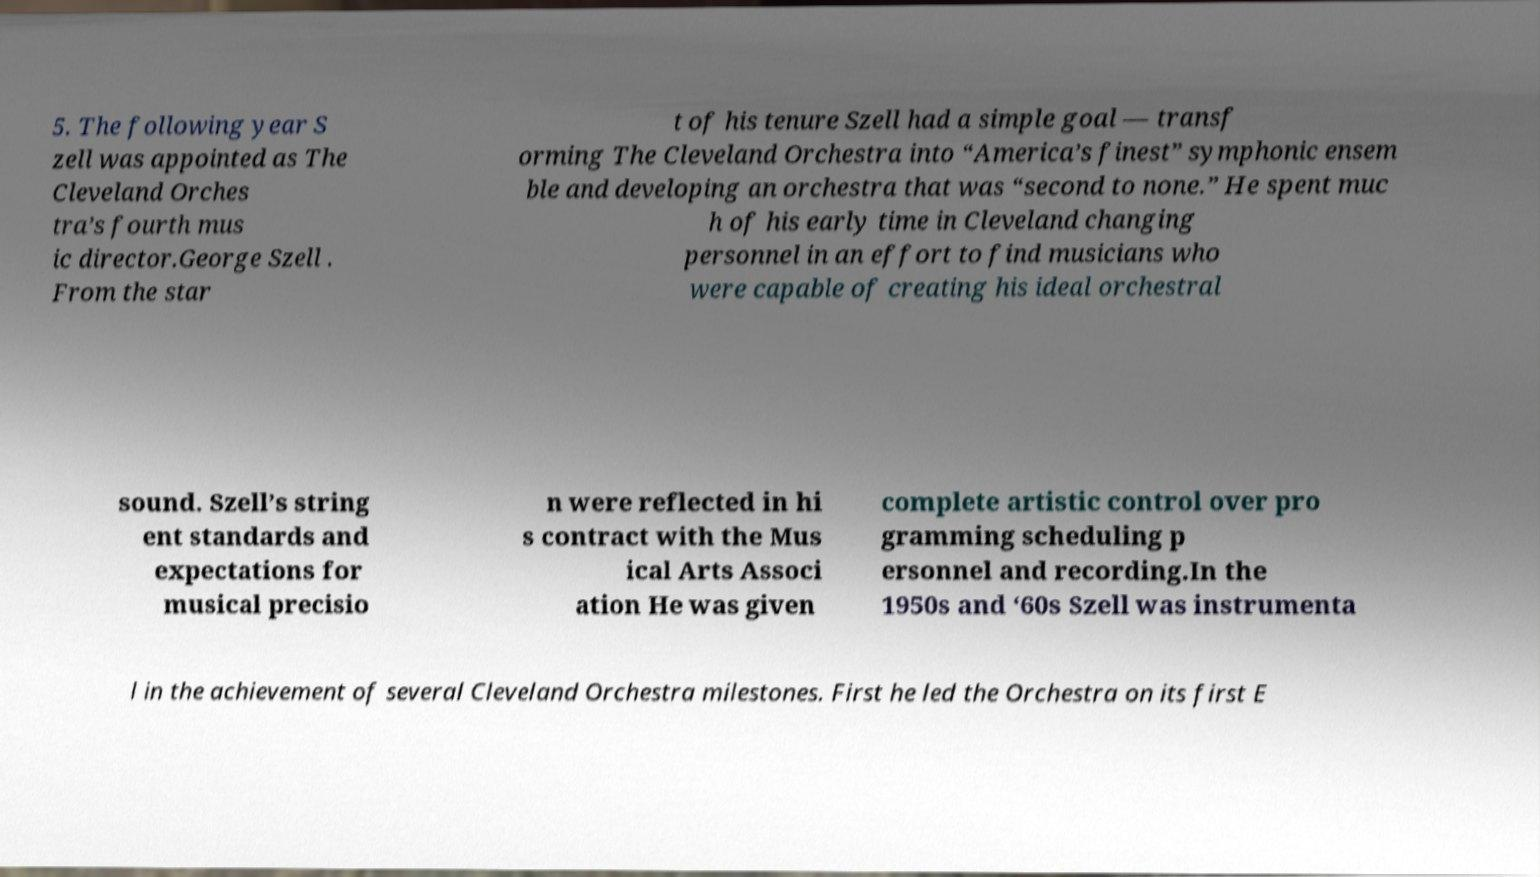Please identify and transcribe the text found in this image. 5. The following year S zell was appointed as The Cleveland Orches tra’s fourth mus ic director.George Szell . From the star t of his tenure Szell had a simple goal — transf orming The Cleveland Orchestra into “America’s finest” symphonic ensem ble and developing an orchestra that was “second to none.” He spent muc h of his early time in Cleveland changing personnel in an effort to find musicians who were capable of creating his ideal orchestral sound. Szell’s string ent standards and expectations for musical precisio n were reflected in hi s contract with the Mus ical Arts Associ ation He was given complete artistic control over pro gramming scheduling p ersonnel and recording.In the 1950s and ‘60s Szell was instrumenta l in the achievement of several Cleveland Orchestra milestones. First he led the Orchestra on its first E 